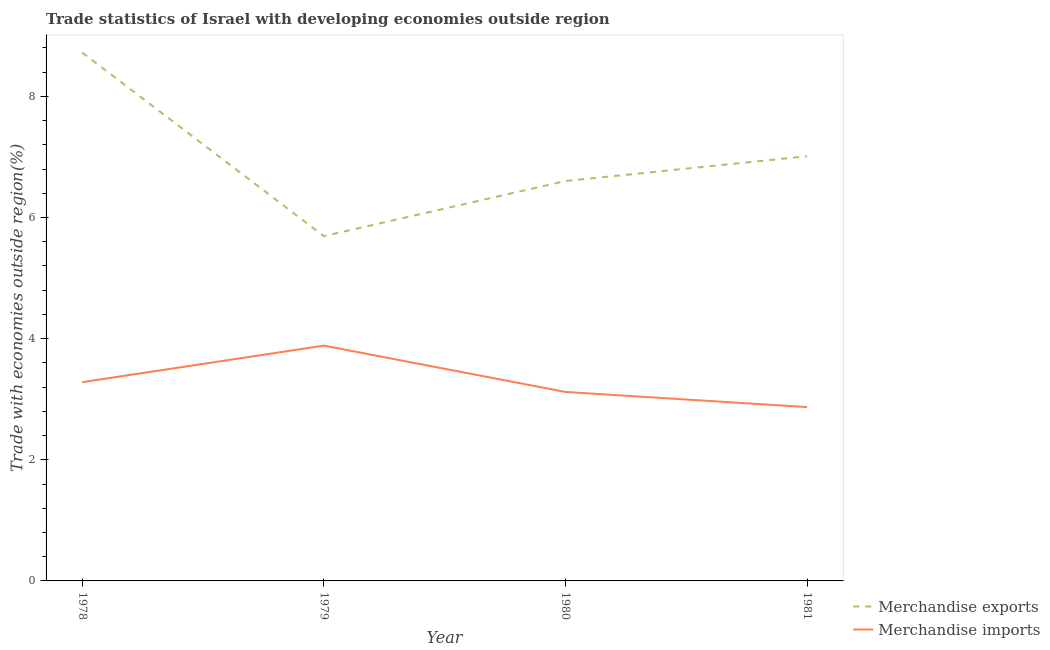How many different coloured lines are there?
Give a very brief answer. 2. Does the line corresponding to merchandise exports intersect with the line corresponding to merchandise imports?
Offer a very short reply. No. Is the number of lines equal to the number of legend labels?
Your answer should be very brief. Yes. What is the merchandise exports in 1980?
Your answer should be very brief. 6.6. Across all years, what is the maximum merchandise imports?
Keep it short and to the point. 3.89. Across all years, what is the minimum merchandise exports?
Your response must be concise. 5.69. In which year was the merchandise imports maximum?
Your answer should be compact. 1979. In which year was the merchandise imports minimum?
Keep it short and to the point. 1981. What is the total merchandise imports in the graph?
Your answer should be very brief. 13.16. What is the difference between the merchandise imports in 1978 and that in 1979?
Give a very brief answer. -0.6. What is the difference between the merchandise exports in 1980 and the merchandise imports in 1978?
Your answer should be compact. 3.32. What is the average merchandise imports per year?
Ensure brevity in your answer.  3.29. In the year 1978, what is the difference between the merchandise imports and merchandise exports?
Your response must be concise. -5.44. What is the ratio of the merchandise exports in 1980 to that in 1981?
Your answer should be very brief. 0.94. Is the merchandise exports in 1979 less than that in 1981?
Keep it short and to the point. Yes. What is the difference between the highest and the second highest merchandise exports?
Provide a short and direct response. 1.71. What is the difference between the highest and the lowest merchandise exports?
Your response must be concise. 3.03. Is the sum of the merchandise imports in 1979 and 1980 greater than the maximum merchandise exports across all years?
Offer a very short reply. No. Does the merchandise exports monotonically increase over the years?
Provide a succinct answer. No. How many lines are there?
Your answer should be very brief. 2. How many years are there in the graph?
Give a very brief answer. 4. What is the difference between two consecutive major ticks on the Y-axis?
Offer a very short reply. 2. Does the graph contain any zero values?
Keep it short and to the point. No. What is the title of the graph?
Provide a short and direct response. Trade statistics of Israel with developing economies outside region. What is the label or title of the X-axis?
Offer a terse response. Year. What is the label or title of the Y-axis?
Give a very brief answer. Trade with economies outside region(%). What is the Trade with economies outside region(%) of Merchandise exports in 1978?
Provide a short and direct response. 8.72. What is the Trade with economies outside region(%) in Merchandise imports in 1978?
Your response must be concise. 3.28. What is the Trade with economies outside region(%) in Merchandise exports in 1979?
Keep it short and to the point. 5.69. What is the Trade with economies outside region(%) in Merchandise imports in 1979?
Provide a succinct answer. 3.89. What is the Trade with economies outside region(%) of Merchandise exports in 1980?
Keep it short and to the point. 6.6. What is the Trade with economies outside region(%) of Merchandise imports in 1980?
Offer a terse response. 3.12. What is the Trade with economies outside region(%) in Merchandise exports in 1981?
Your response must be concise. 7.01. What is the Trade with economies outside region(%) of Merchandise imports in 1981?
Offer a terse response. 2.87. Across all years, what is the maximum Trade with economies outside region(%) of Merchandise exports?
Your response must be concise. 8.72. Across all years, what is the maximum Trade with economies outside region(%) in Merchandise imports?
Make the answer very short. 3.89. Across all years, what is the minimum Trade with economies outside region(%) of Merchandise exports?
Make the answer very short. 5.69. Across all years, what is the minimum Trade with economies outside region(%) in Merchandise imports?
Your answer should be compact. 2.87. What is the total Trade with economies outside region(%) in Merchandise exports in the graph?
Your answer should be very brief. 28.03. What is the total Trade with economies outside region(%) of Merchandise imports in the graph?
Give a very brief answer. 13.16. What is the difference between the Trade with economies outside region(%) in Merchandise exports in 1978 and that in 1979?
Provide a succinct answer. 3.03. What is the difference between the Trade with economies outside region(%) in Merchandise imports in 1978 and that in 1979?
Provide a succinct answer. -0.6. What is the difference between the Trade with economies outside region(%) in Merchandise exports in 1978 and that in 1980?
Your response must be concise. 2.12. What is the difference between the Trade with economies outside region(%) in Merchandise imports in 1978 and that in 1980?
Your answer should be very brief. 0.16. What is the difference between the Trade with economies outside region(%) of Merchandise exports in 1978 and that in 1981?
Provide a succinct answer. 1.71. What is the difference between the Trade with economies outside region(%) of Merchandise imports in 1978 and that in 1981?
Provide a succinct answer. 0.41. What is the difference between the Trade with economies outside region(%) in Merchandise exports in 1979 and that in 1980?
Your answer should be compact. -0.91. What is the difference between the Trade with economies outside region(%) of Merchandise imports in 1979 and that in 1980?
Your response must be concise. 0.76. What is the difference between the Trade with economies outside region(%) in Merchandise exports in 1979 and that in 1981?
Offer a terse response. -1.32. What is the difference between the Trade with economies outside region(%) of Merchandise exports in 1980 and that in 1981?
Provide a succinct answer. -0.41. What is the difference between the Trade with economies outside region(%) of Merchandise exports in 1978 and the Trade with economies outside region(%) of Merchandise imports in 1979?
Ensure brevity in your answer.  4.84. What is the difference between the Trade with economies outside region(%) of Merchandise exports in 1978 and the Trade with economies outside region(%) of Merchandise imports in 1980?
Offer a terse response. 5.6. What is the difference between the Trade with economies outside region(%) in Merchandise exports in 1978 and the Trade with economies outside region(%) in Merchandise imports in 1981?
Your answer should be compact. 5.85. What is the difference between the Trade with economies outside region(%) in Merchandise exports in 1979 and the Trade with economies outside region(%) in Merchandise imports in 1980?
Give a very brief answer. 2.57. What is the difference between the Trade with economies outside region(%) of Merchandise exports in 1979 and the Trade with economies outside region(%) of Merchandise imports in 1981?
Offer a terse response. 2.82. What is the difference between the Trade with economies outside region(%) in Merchandise exports in 1980 and the Trade with economies outside region(%) in Merchandise imports in 1981?
Your answer should be compact. 3.73. What is the average Trade with economies outside region(%) of Merchandise exports per year?
Your answer should be very brief. 7.01. What is the average Trade with economies outside region(%) in Merchandise imports per year?
Your answer should be compact. 3.29. In the year 1978, what is the difference between the Trade with economies outside region(%) in Merchandise exports and Trade with economies outside region(%) in Merchandise imports?
Ensure brevity in your answer.  5.44. In the year 1979, what is the difference between the Trade with economies outside region(%) in Merchandise exports and Trade with economies outside region(%) in Merchandise imports?
Provide a short and direct response. 1.81. In the year 1980, what is the difference between the Trade with economies outside region(%) of Merchandise exports and Trade with economies outside region(%) of Merchandise imports?
Provide a short and direct response. 3.48. In the year 1981, what is the difference between the Trade with economies outside region(%) of Merchandise exports and Trade with economies outside region(%) of Merchandise imports?
Your response must be concise. 4.14. What is the ratio of the Trade with economies outside region(%) in Merchandise exports in 1978 to that in 1979?
Offer a terse response. 1.53. What is the ratio of the Trade with economies outside region(%) in Merchandise imports in 1978 to that in 1979?
Provide a short and direct response. 0.84. What is the ratio of the Trade with economies outside region(%) of Merchandise exports in 1978 to that in 1980?
Give a very brief answer. 1.32. What is the ratio of the Trade with economies outside region(%) in Merchandise imports in 1978 to that in 1980?
Keep it short and to the point. 1.05. What is the ratio of the Trade with economies outside region(%) in Merchandise exports in 1978 to that in 1981?
Give a very brief answer. 1.24. What is the ratio of the Trade with economies outside region(%) in Merchandise imports in 1978 to that in 1981?
Offer a terse response. 1.14. What is the ratio of the Trade with economies outside region(%) in Merchandise exports in 1979 to that in 1980?
Offer a very short reply. 0.86. What is the ratio of the Trade with economies outside region(%) in Merchandise imports in 1979 to that in 1980?
Keep it short and to the point. 1.25. What is the ratio of the Trade with economies outside region(%) of Merchandise exports in 1979 to that in 1981?
Offer a terse response. 0.81. What is the ratio of the Trade with economies outside region(%) in Merchandise imports in 1979 to that in 1981?
Offer a very short reply. 1.35. What is the ratio of the Trade with economies outside region(%) of Merchandise exports in 1980 to that in 1981?
Ensure brevity in your answer.  0.94. What is the ratio of the Trade with economies outside region(%) in Merchandise imports in 1980 to that in 1981?
Provide a short and direct response. 1.09. What is the difference between the highest and the second highest Trade with economies outside region(%) in Merchandise exports?
Offer a terse response. 1.71. What is the difference between the highest and the second highest Trade with economies outside region(%) in Merchandise imports?
Provide a succinct answer. 0.6. What is the difference between the highest and the lowest Trade with economies outside region(%) in Merchandise exports?
Your answer should be compact. 3.03. 